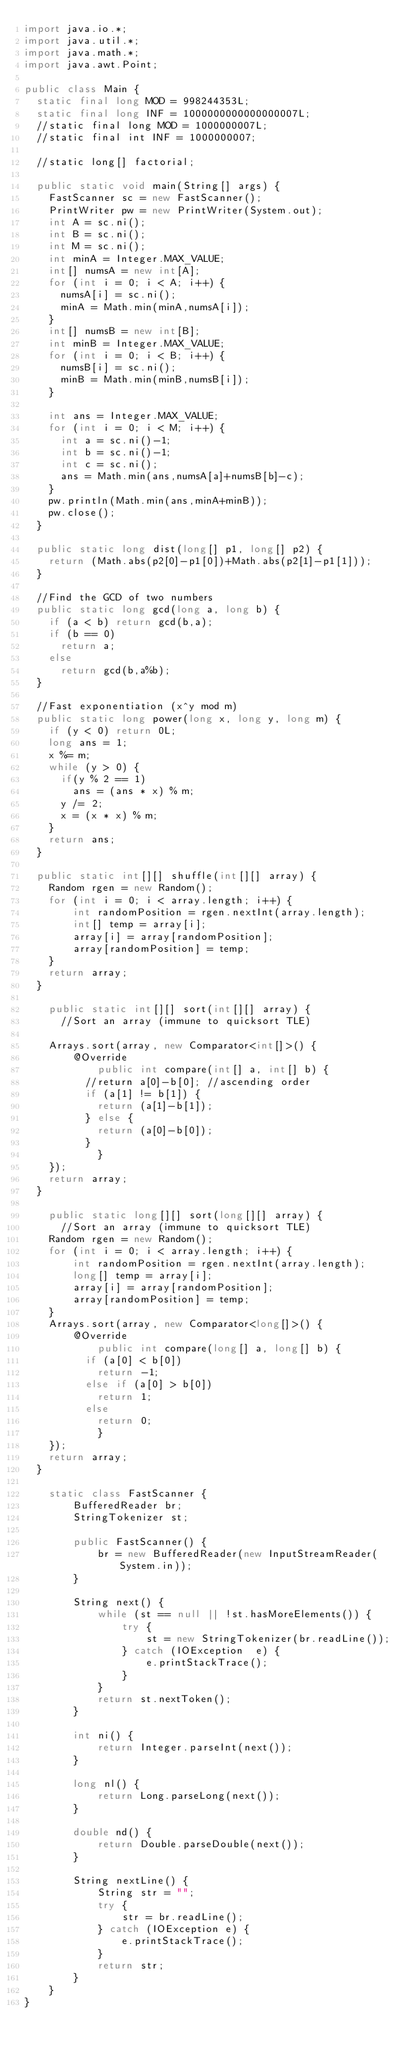<code> <loc_0><loc_0><loc_500><loc_500><_Java_>import java.io.*;
import java.util.*;
import java.math.*;
import java.awt.Point;
 
public class Main {
	static final long MOD = 998244353L;
	static final long INF = 1000000000000000007L;
	//static final long MOD = 1000000007L;
	//static final int INF = 1000000007;
	
	//static long[] factorial;
	
	public static void main(String[] args) {
		FastScanner sc = new FastScanner();
		PrintWriter pw = new PrintWriter(System.out);
		int A = sc.ni();
		int B = sc.ni();
		int M = sc.ni();
		int minA = Integer.MAX_VALUE;
		int[] numsA = new int[A];
		for (int i = 0; i < A; i++) {
			numsA[i] = sc.ni();
			minA = Math.min(minA,numsA[i]);
		}
		int[] numsB = new int[B];
		int minB = Integer.MAX_VALUE;
		for (int i = 0; i < B; i++) {
			numsB[i] = sc.ni();
			minB = Math.min(minB,numsB[i]);
		}
		
		int ans = Integer.MAX_VALUE;
		for (int i = 0; i < M; i++) {
			int a = sc.ni()-1;
			int b = sc.ni()-1;
			int c = sc.ni();
			ans = Math.min(ans,numsA[a]+numsB[b]-c);
		}
		pw.println(Math.min(ans,minA+minB));
		pw.close();
	}
	
	public static long dist(long[] p1, long[] p2) {
		return (Math.abs(p2[0]-p1[0])+Math.abs(p2[1]-p1[1]));
	}
	
	//Find the GCD of two numbers
	public static long gcd(long a, long b) {
		if (a < b) return gcd(b,a);
		if (b == 0)
			return a;
		else
			return gcd(b,a%b);
	}
	
	//Fast exponentiation (x^y mod m)
	public static long power(long x, long y, long m) { 
		if (y < 0) return 0L;
		long ans = 1;
		x %= m;
		while (y > 0) { 
			if(y % 2 == 1) 
				ans = (ans * x) % m; 
			y /= 2;  
			x = (x * x) % m;
		} 
		return ans; 
	}
	
	public static int[][] shuffle(int[][] array) {
		Random rgen = new Random();
		for (int i = 0; i < array.length; i++) {
		    int randomPosition = rgen.nextInt(array.length);
		    int[] temp = array[i];
		    array[i] = array[randomPosition];
		    array[randomPosition] = temp;
		}
		return array;
	}
	
    public static int[][] sort(int[][] array) {
    	//Sort an array (immune to quicksort TLE)
 
		Arrays.sort(array, new Comparator<int[]>() {
			  @Override
        	  public int compare(int[] a, int[] b) {
				  //return a[0]-b[0]; //ascending order
				  if (a[1] != b[1]) {
					  return (a[1]-b[1]);
				  } else {
					  return (a[0]-b[0]);
				  }
	          }
		});
		return array;
	}
    
    public static long[][] sort(long[][] array) {
    	//Sort an array (immune to quicksort TLE)
		Random rgen = new Random();
		for (int i = 0; i < array.length; i++) {
		    int randomPosition = rgen.nextInt(array.length);
		    long[] temp = array[i];
		    array[i] = array[randomPosition];
		    array[randomPosition] = temp;
		}
		Arrays.sort(array, new Comparator<long[]>() {
			  @Override
        	  public int compare(long[] a, long[] b) {
				  if (a[0] < b[0])
					  return -1;
				  else if (a[0] > b[0])
					  return 1;
				  else
					  return 0;
	          }
		});
		return array;
	}
    
    static class FastScanner { 
        BufferedReader br; 
        StringTokenizer st; 
  
        public FastScanner() { 
            br = new BufferedReader(new InputStreamReader(System.in)); 
        } 
  
        String next() { 
            while (st == null || !st.hasMoreElements()) { 
                try { 
                    st = new StringTokenizer(br.readLine());
                } catch (IOException  e) { 
                    e.printStackTrace(); 
                } 
            } 
            return st.nextToken(); 
        } 
  
        int ni() { 
            return Integer.parseInt(next()); 
        } 
  
        long nl() { 
            return Long.parseLong(next()); 
        } 
  
        double nd() { 
            return Double.parseDouble(next()); 
        } 
  
        String nextLine() {
            String str = ""; 
            try { 
                str = br.readLine(); 
            } catch (IOException e) {
                e.printStackTrace(); 
            } 
            return str;
        }
    }
}</code> 